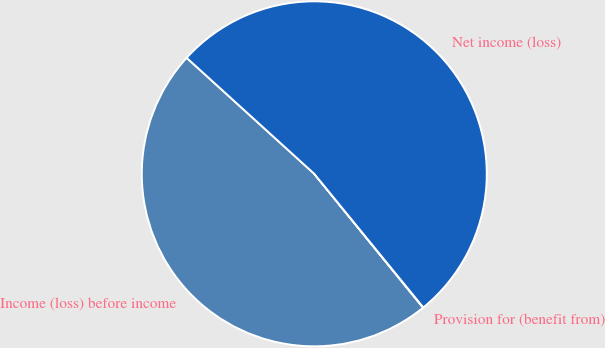<chart> <loc_0><loc_0><loc_500><loc_500><pie_chart><fcel>Income (loss) before income<fcel>Provision for (benefit from)<fcel>Net income (loss)<nl><fcel>47.6%<fcel>0.03%<fcel>52.36%<nl></chart> 